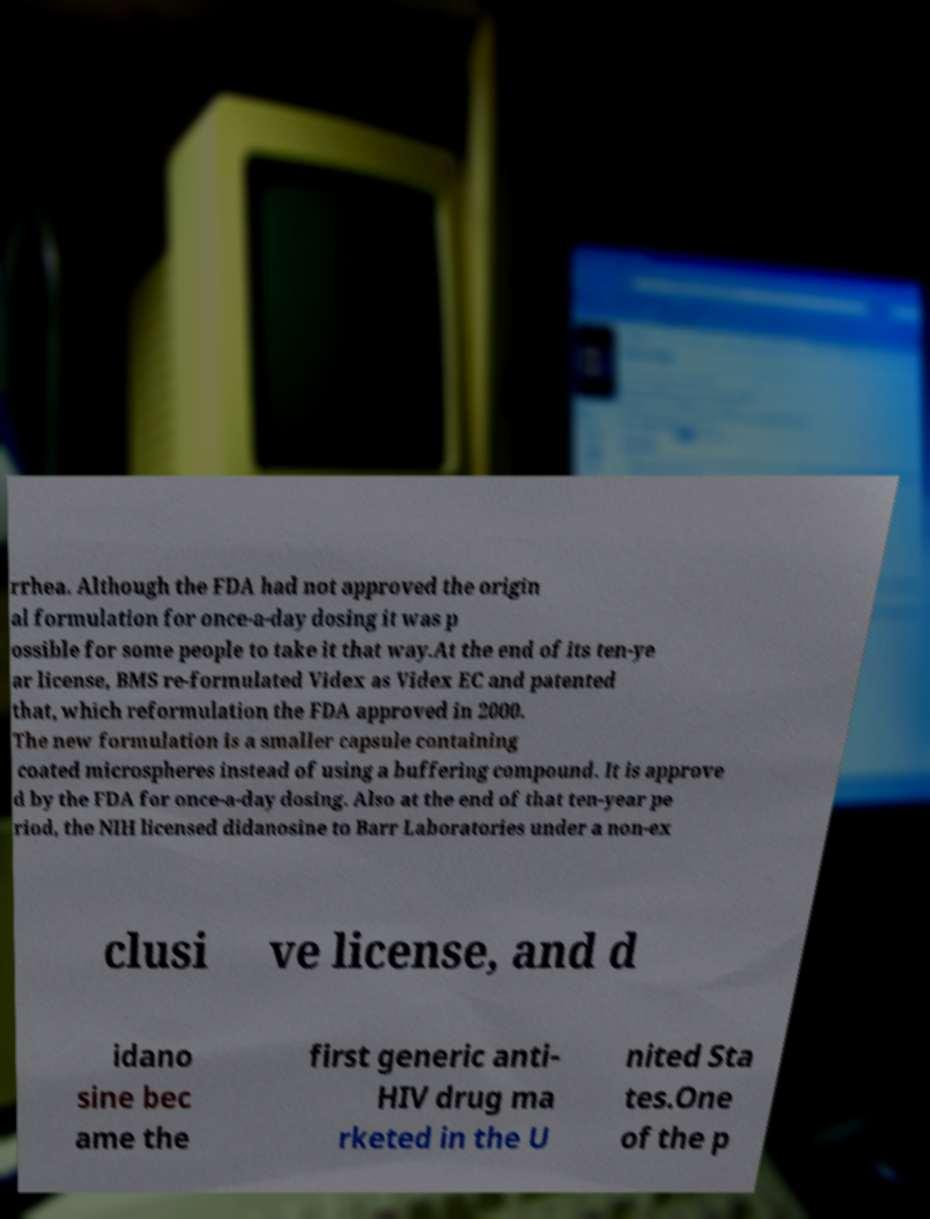Could you assist in decoding the text presented in this image and type it out clearly? rrhea. Although the FDA had not approved the origin al formulation for once-a-day dosing it was p ossible for some people to take it that way.At the end of its ten-ye ar license, BMS re-formulated Videx as Videx EC and patented that, which reformulation the FDA approved in 2000. The new formulation is a smaller capsule containing coated microspheres instead of using a buffering compound. It is approve d by the FDA for once-a-day dosing. Also at the end of that ten-year pe riod, the NIH licensed didanosine to Barr Laboratories under a non-ex clusi ve license, and d idano sine bec ame the first generic anti- HIV drug ma rketed in the U nited Sta tes.One of the p 